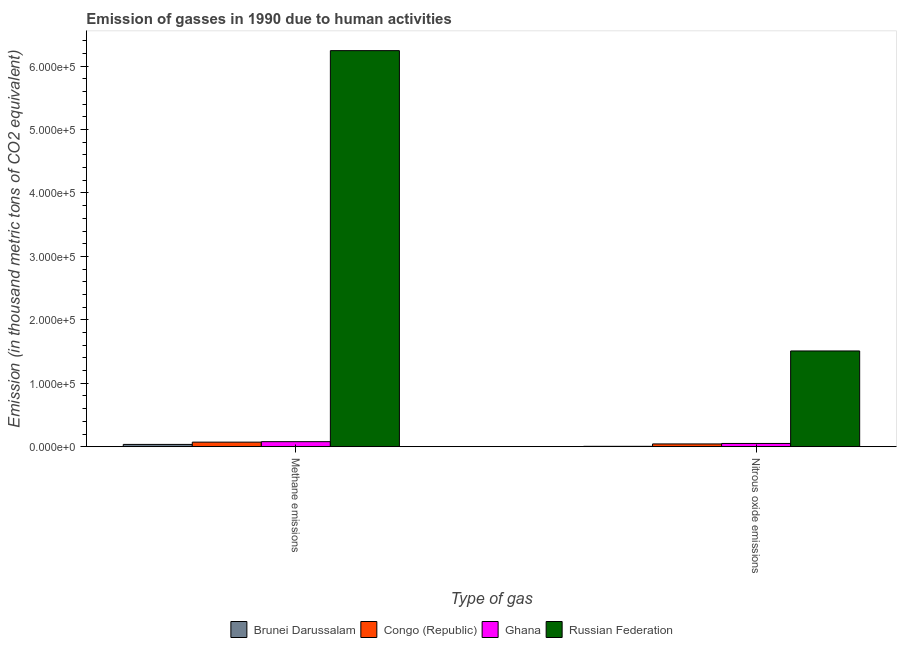How many different coloured bars are there?
Ensure brevity in your answer.  4. How many bars are there on the 1st tick from the right?
Offer a very short reply. 4. What is the label of the 1st group of bars from the left?
Provide a succinct answer. Methane emissions. What is the amount of nitrous oxide emissions in Ghana?
Your answer should be compact. 5101.4. Across all countries, what is the maximum amount of nitrous oxide emissions?
Ensure brevity in your answer.  1.51e+05. Across all countries, what is the minimum amount of methane emissions?
Keep it short and to the point. 3591.9. In which country was the amount of methane emissions maximum?
Keep it short and to the point. Russian Federation. In which country was the amount of methane emissions minimum?
Your response must be concise. Brunei Darussalam. What is the total amount of methane emissions in the graph?
Provide a short and direct response. 6.43e+05. What is the difference between the amount of nitrous oxide emissions in Congo (Republic) and that in Brunei Darussalam?
Your answer should be very brief. 3780.4. What is the difference between the amount of methane emissions in Congo (Republic) and the amount of nitrous oxide emissions in Russian Federation?
Provide a short and direct response. -1.44e+05. What is the average amount of nitrous oxide emissions per country?
Your answer should be compact. 4.02e+04. What is the difference between the amount of methane emissions and amount of nitrous oxide emissions in Congo (Republic)?
Offer a terse response. 2842.7. What is the ratio of the amount of nitrous oxide emissions in Congo (Republic) to that in Ghana?
Offer a very short reply. 0.85. Is the amount of methane emissions in Ghana less than that in Congo (Republic)?
Your answer should be compact. No. What does the 1st bar from the right in Nitrous oxide emissions represents?
Provide a succinct answer. Russian Federation. Are all the bars in the graph horizontal?
Ensure brevity in your answer.  No. Does the graph contain grids?
Provide a succinct answer. No. Where does the legend appear in the graph?
Your answer should be compact. Bottom center. What is the title of the graph?
Provide a short and direct response. Emission of gasses in 1990 due to human activities. What is the label or title of the X-axis?
Your response must be concise. Type of gas. What is the label or title of the Y-axis?
Your answer should be compact. Emission (in thousand metric tons of CO2 equivalent). What is the Emission (in thousand metric tons of CO2 equivalent) in Brunei Darussalam in Methane emissions?
Provide a succinct answer. 3591.9. What is the Emission (in thousand metric tons of CO2 equivalent) in Congo (Republic) in Methane emissions?
Offer a very short reply. 7194.2. What is the Emission (in thousand metric tons of CO2 equivalent) in Ghana in Methane emissions?
Keep it short and to the point. 7924.7. What is the Emission (in thousand metric tons of CO2 equivalent) in Russian Federation in Methane emissions?
Offer a terse response. 6.24e+05. What is the Emission (in thousand metric tons of CO2 equivalent) in Brunei Darussalam in Nitrous oxide emissions?
Offer a very short reply. 571.1. What is the Emission (in thousand metric tons of CO2 equivalent) of Congo (Republic) in Nitrous oxide emissions?
Your response must be concise. 4351.5. What is the Emission (in thousand metric tons of CO2 equivalent) of Ghana in Nitrous oxide emissions?
Your response must be concise. 5101.4. What is the Emission (in thousand metric tons of CO2 equivalent) in Russian Federation in Nitrous oxide emissions?
Your answer should be compact. 1.51e+05. Across all Type of gas, what is the maximum Emission (in thousand metric tons of CO2 equivalent) in Brunei Darussalam?
Your response must be concise. 3591.9. Across all Type of gas, what is the maximum Emission (in thousand metric tons of CO2 equivalent) of Congo (Republic)?
Make the answer very short. 7194.2. Across all Type of gas, what is the maximum Emission (in thousand metric tons of CO2 equivalent) in Ghana?
Provide a succinct answer. 7924.7. Across all Type of gas, what is the maximum Emission (in thousand metric tons of CO2 equivalent) of Russian Federation?
Offer a very short reply. 6.24e+05. Across all Type of gas, what is the minimum Emission (in thousand metric tons of CO2 equivalent) in Brunei Darussalam?
Provide a short and direct response. 571.1. Across all Type of gas, what is the minimum Emission (in thousand metric tons of CO2 equivalent) of Congo (Republic)?
Provide a succinct answer. 4351.5. Across all Type of gas, what is the minimum Emission (in thousand metric tons of CO2 equivalent) in Ghana?
Your answer should be very brief. 5101.4. Across all Type of gas, what is the minimum Emission (in thousand metric tons of CO2 equivalent) in Russian Federation?
Offer a terse response. 1.51e+05. What is the total Emission (in thousand metric tons of CO2 equivalent) in Brunei Darussalam in the graph?
Give a very brief answer. 4163. What is the total Emission (in thousand metric tons of CO2 equivalent) of Congo (Republic) in the graph?
Your answer should be compact. 1.15e+04. What is the total Emission (in thousand metric tons of CO2 equivalent) in Ghana in the graph?
Provide a short and direct response. 1.30e+04. What is the total Emission (in thousand metric tons of CO2 equivalent) of Russian Federation in the graph?
Your response must be concise. 7.75e+05. What is the difference between the Emission (in thousand metric tons of CO2 equivalent) of Brunei Darussalam in Methane emissions and that in Nitrous oxide emissions?
Provide a short and direct response. 3020.8. What is the difference between the Emission (in thousand metric tons of CO2 equivalent) in Congo (Republic) in Methane emissions and that in Nitrous oxide emissions?
Give a very brief answer. 2842.7. What is the difference between the Emission (in thousand metric tons of CO2 equivalent) of Ghana in Methane emissions and that in Nitrous oxide emissions?
Give a very brief answer. 2823.3. What is the difference between the Emission (in thousand metric tons of CO2 equivalent) of Russian Federation in Methane emissions and that in Nitrous oxide emissions?
Ensure brevity in your answer.  4.74e+05. What is the difference between the Emission (in thousand metric tons of CO2 equivalent) in Brunei Darussalam in Methane emissions and the Emission (in thousand metric tons of CO2 equivalent) in Congo (Republic) in Nitrous oxide emissions?
Give a very brief answer. -759.6. What is the difference between the Emission (in thousand metric tons of CO2 equivalent) of Brunei Darussalam in Methane emissions and the Emission (in thousand metric tons of CO2 equivalent) of Ghana in Nitrous oxide emissions?
Your answer should be very brief. -1509.5. What is the difference between the Emission (in thousand metric tons of CO2 equivalent) of Brunei Darussalam in Methane emissions and the Emission (in thousand metric tons of CO2 equivalent) of Russian Federation in Nitrous oxide emissions?
Your answer should be very brief. -1.47e+05. What is the difference between the Emission (in thousand metric tons of CO2 equivalent) in Congo (Republic) in Methane emissions and the Emission (in thousand metric tons of CO2 equivalent) in Ghana in Nitrous oxide emissions?
Keep it short and to the point. 2092.8. What is the difference between the Emission (in thousand metric tons of CO2 equivalent) of Congo (Republic) in Methane emissions and the Emission (in thousand metric tons of CO2 equivalent) of Russian Federation in Nitrous oxide emissions?
Give a very brief answer. -1.44e+05. What is the difference between the Emission (in thousand metric tons of CO2 equivalent) in Ghana in Methane emissions and the Emission (in thousand metric tons of CO2 equivalent) in Russian Federation in Nitrous oxide emissions?
Ensure brevity in your answer.  -1.43e+05. What is the average Emission (in thousand metric tons of CO2 equivalent) of Brunei Darussalam per Type of gas?
Provide a short and direct response. 2081.5. What is the average Emission (in thousand metric tons of CO2 equivalent) of Congo (Republic) per Type of gas?
Offer a terse response. 5772.85. What is the average Emission (in thousand metric tons of CO2 equivalent) of Ghana per Type of gas?
Your response must be concise. 6513.05. What is the average Emission (in thousand metric tons of CO2 equivalent) in Russian Federation per Type of gas?
Your answer should be compact. 3.88e+05. What is the difference between the Emission (in thousand metric tons of CO2 equivalent) of Brunei Darussalam and Emission (in thousand metric tons of CO2 equivalent) of Congo (Republic) in Methane emissions?
Ensure brevity in your answer.  -3602.3. What is the difference between the Emission (in thousand metric tons of CO2 equivalent) in Brunei Darussalam and Emission (in thousand metric tons of CO2 equivalent) in Ghana in Methane emissions?
Offer a terse response. -4332.8. What is the difference between the Emission (in thousand metric tons of CO2 equivalent) of Brunei Darussalam and Emission (in thousand metric tons of CO2 equivalent) of Russian Federation in Methane emissions?
Provide a succinct answer. -6.21e+05. What is the difference between the Emission (in thousand metric tons of CO2 equivalent) in Congo (Republic) and Emission (in thousand metric tons of CO2 equivalent) in Ghana in Methane emissions?
Your answer should be compact. -730.5. What is the difference between the Emission (in thousand metric tons of CO2 equivalent) in Congo (Republic) and Emission (in thousand metric tons of CO2 equivalent) in Russian Federation in Methane emissions?
Keep it short and to the point. -6.17e+05. What is the difference between the Emission (in thousand metric tons of CO2 equivalent) in Ghana and Emission (in thousand metric tons of CO2 equivalent) in Russian Federation in Methane emissions?
Ensure brevity in your answer.  -6.17e+05. What is the difference between the Emission (in thousand metric tons of CO2 equivalent) of Brunei Darussalam and Emission (in thousand metric tons of CO2 equivalent) of Congo (Republic) in Nitrous oxide emissions?
Your answer should be compact. -3780.4. What is the difference between the Emission (in thousand metric tons of CO2 equivalent) in Brunei Darussalam and Emission (in thousand metric tons of CO2 equivalent) in Ghana in Nitrous oxide emissions?
Your answer should be very brief. -4530.3. What is the difference between the Emission (in thousand metric tons of CO2 equivalent) in Brunei Darussalam and Emission (in thousand metric tons of CO2 equivalent) in Russian Federation in Nitrous oxide emissions?
Your response must be concise. -1.50e+05. What is the difference between the Emission (in thousand metric tons of CO2 equivalent) in Congo (Republic) and Emission (in thousand metric tons of CO2 equivalent) in Ghana in Nitrous oxide emissions?
Offer a terse response. -749.9. What is the difference between the Emission (in thousand metric tons of CO2 equivalent) in Congo (Republic) and Emission (in thousand metric tons of CO2 equivalent) in Russian Federation in Nitrous oxide emissions?
Offer a terse response. -1.47e+05. What is the difference between the Emission (in thousand metric tons of CO2 equivalent) in Ghana and Emission (in thousand metric tons of CO2 equivalent) in Russian Federation in Nitrous oxide emissions?
Offer a terse response. -1.46e+05. What is the ratio of the Emission (in thousand metric tons of CO2 equivalent) of Brunei Darussalam in Methane emissions to that in Nitrous oxide emissions?
Your answer should be compact. 6.29. What is the ratio of the Emission (in thousand metric tons of CO2 equivalent) in Congo (Republic) in Methane emissions to that in Nitrous oxide emissions?
Keep it short and to the point. 1.65. What is the ratio of the Emission (in thousand metric tons of CO2 equivalent) in Ghana in Methane emissions to that in Nitrous oxide emissions?
Keep it short and to the point. 1.55. What is the ratio of the Emission (in thousand metric tons of CO2 equivalent) in Russian Federation in Methane emissions to that in Nitrous oxide emissions?
Offer a very short reply. 4.14. What is the difference between the highest and the second highest Emission (in thousand metric tons of CO2 equivalent) in Brunei Darussalam?
Provide a succinct answer. 3020.8. What is the difference between the highest and the second highest Emission (in thousand metric tons of CO2 equivalent) in Congo (Republic)?
Provide a short and direct response. 2842.7. What is the difference between the highest and the second highest Emission (in thousand metric tons of CO2 equivalent) of Ghana?
Give a very brief answer. 2823.3. What is the difference between the highest and the second highest Emission (in thousand metric tons of CO2 equivalent) in Russian Federation?
Ensure brevity in your answer.  4.74e+05. What is the difference between the highest and the lowest Emission (in thousand metric tons of CO2 equivalent) in Brunei Darussalam?
Ensure brevity in your answer.  3020.8. What is the difference between the highest and the lowest Emission (in thousand metric tons of CO2 equivalent) in Congo (Republic)?
Make the answer very short. 2842.7. What is the difference between the highest and the lowest Emission (in thousand metric tons of CO2 equivalent) of Ghana?
Offer a very short reply. 2823.3. What is the difference between the highest and the lowest Emission (in thousand metric tons of CO2 equivalent) in Russian Federation?
Offer a terse response. 4.74e+05. 